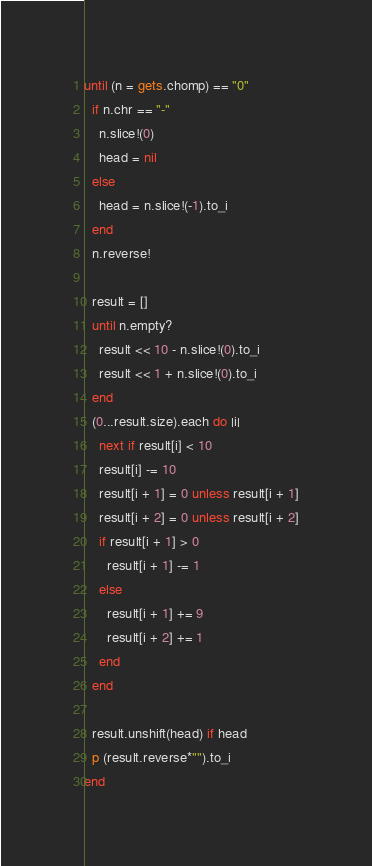Convert code to text. <code><loc_0><loc_0><loc_500><loc_500><_Ruby_>until (n = gets.chomp) == "0"
  if n.chr == "-"
    n.slice!(0)
    head = nil
  else
    head = n.slice!(-1).to_i
  end
  n.reverse!

  result = []
  until n.empty?
    result << 10 - n.slice!(0).to_i
    result << 1 + n.slice!(0).to_i
  end
  (0...result.size).each do |i|
    next if result[i] < 10
    result[i] -= 10
    result[i + 1] = 0 unless result[i + 1]
    result[i + 2] = 0 unless result[i + 2]
    if result[i + 1] > 0
      result[i + 1] -= 1
    else
      result[i + 1] += 9
      result[i + 2] += 1
    end
  end

  result.unshift(head) if head
  p (result.reverse*"").to_i
end</code> 